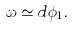<formula> <loc_0><loc_0><loc_500><loc_500>\omega \simeq d \phi _ { 1 } .</formula> 